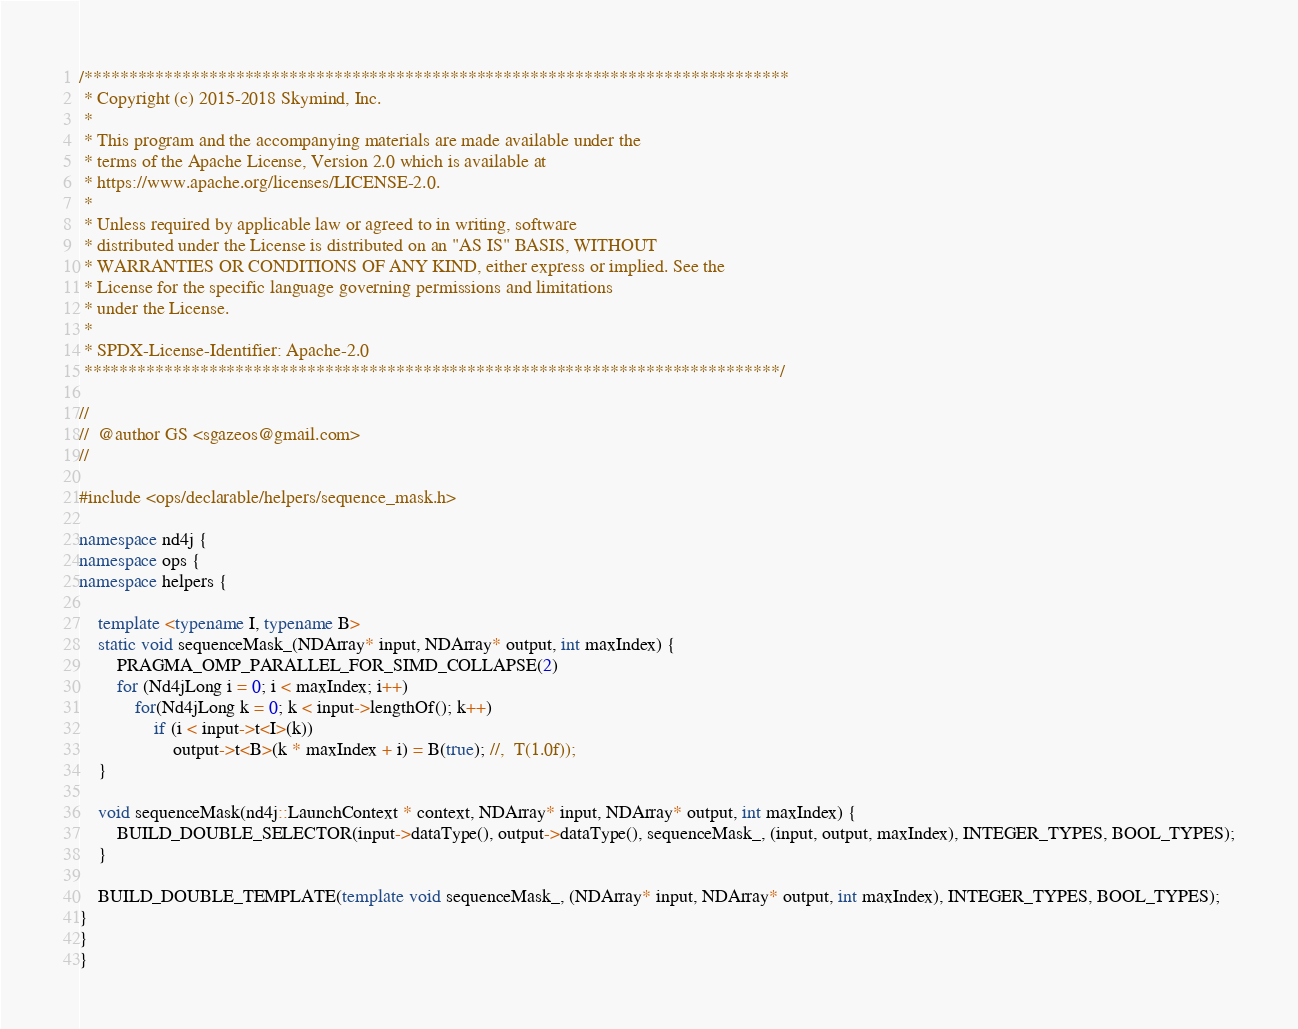<code> <loc_0><loc_0><loc_500><loc_500><_C++_>/*******************************************************************************
 * Copyright (c) 2015-2018 Skymind, Inc.
 *
 * This program and the accompanying materials are made available under the
 * terms of the Apache License, Version 2.0 which is available at
 * https://www.apache.org/licenses/LICENSE-2.0.
 *
 * Unless required by applicable law or agreed to in writing, software
 * distributed under the License is distributed on an "AS IS" BASIS, WITHOUT
 * WARRANTIES OR CONDITIONS OF ANY KIND, either express or implied. See the
 * License for the specific language governing permissions and limitations
 * under the License.
 *
 * SPDX-License-Identifier: Apache-2.0
 ******************************************************************************/

//
//  @author GS <sgazeos@gmail.com>
//

#include <ops/declarable/helpers/sequence_mask.h>

namespace nd4j {
namespace ops {
namespace helpers {

    template <typename I, typename B>
    static void sequenceMask_(NDArray* input, NDArray* output, int maxIndex) {
        PRAGMA_OMP_PARALLEL_FOR_SIMD_COLLAPSE(2)
        for (Nd4jLong i = 0; i < maxIndex; i++)
            for(Nd4jLong k = 0; k < input->lengthOf(); k++)
                if (i < input->t<I>(k))
                    output->t<B>(k * maxIndex + i) = B(true); //,  T(1.0f));
    }

    void sequenceMask(nd4j::LaunchContext * context, NDArray* input, NDArray* output, int maxIndex) {
        BUILD_DOUBLE_SELECTOR(input->dataType(), output->dataType(), sequenceMask_, (input, output, maxIndex), INTEGER_TYPES, BOOL_TYPES);
    }

    BUILD_DOUBLE_TEMPLATE(template void sequenceMask_, (NDArray* input, NDArray* output, int maxIndex), INTEGER_TYPES, BOOL_TYPES);
}
}
}</code> 